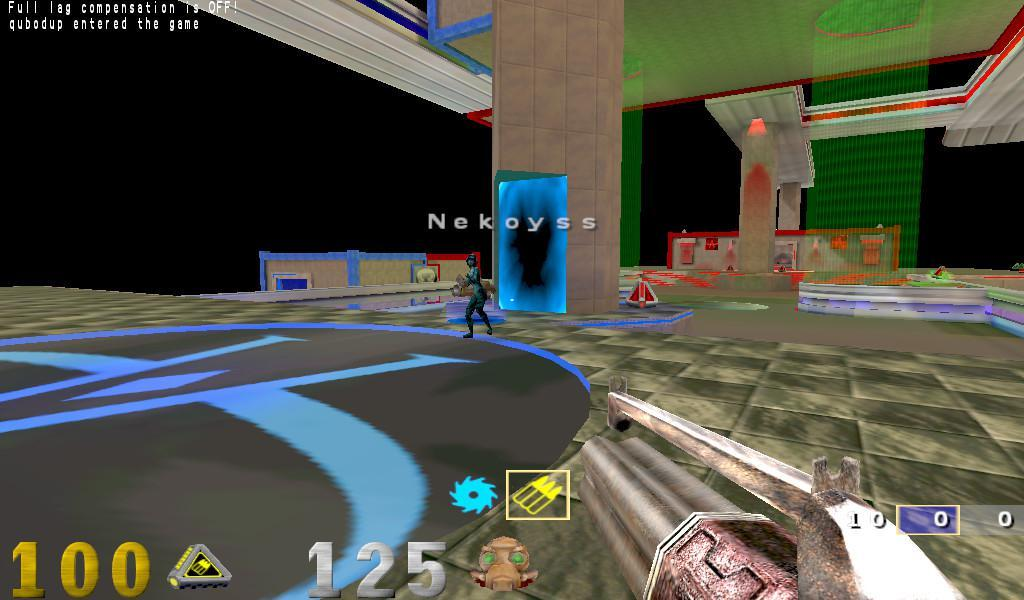Who or what is present in the image? There is a person in the image. What architectural features can be seen in the image? There are pillars, a wall, and a roof in the image. What is on the ground in the image? There are objects on the ground in the image. How many crows are sitting on the roof in the image? There are no crows present in the image. What type of sorting algorithm is being used by the person in the image? The image does not provide any information about sorting algorithms or the person's actions. 